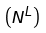<formula> <loc_0><loc_0><loc_500><loc_500>\left ( { N } ^ { L } \right )</formula> 